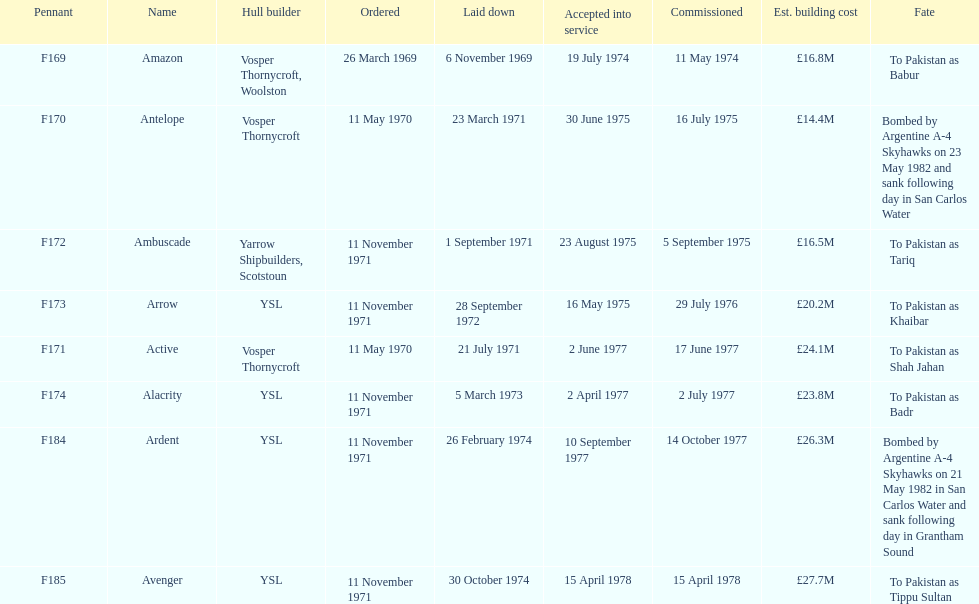The arrow was ordered on november 11, 1971. what was the previous ship? Ambuscade. 